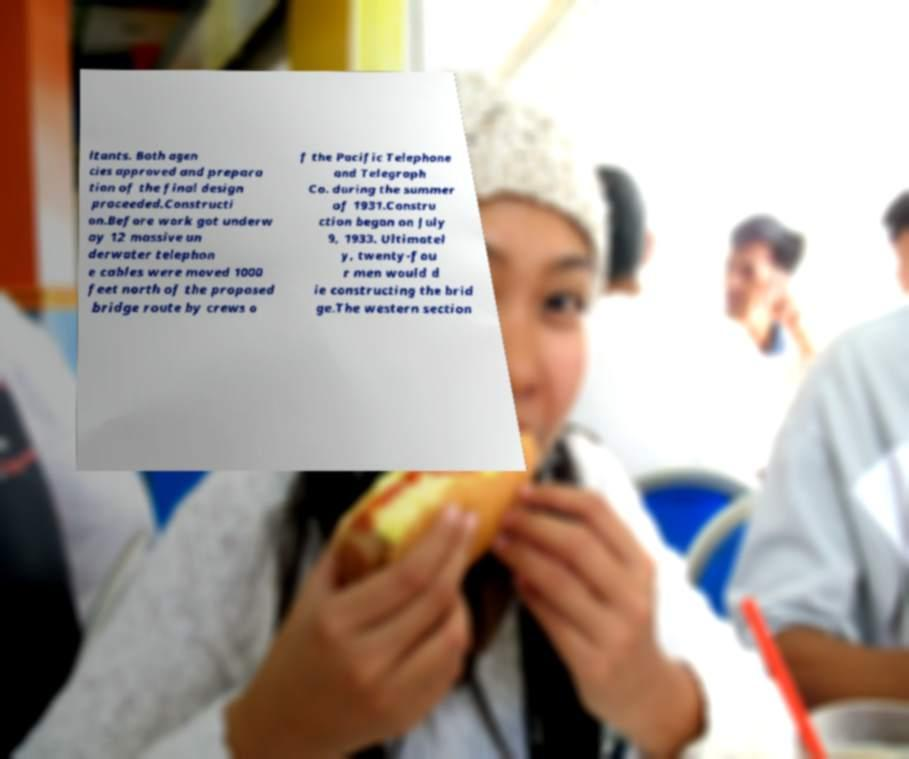Please identify and transcribe the text found in this image. ltants. Both agen cies approved and prepara tion of the final design proceeded.Constructi on.Before work got underw ay 12 massive un derwater telephon e cables were moved 1000 feet north of the proposed bridge route by crews o f the Pacific Telephone and Telegraph Co. during the summer of 1931.Constru ction began on July 9, 1933. Ultimatel y, twenty-fou r men would d ie constructing the brid ge.The western section 